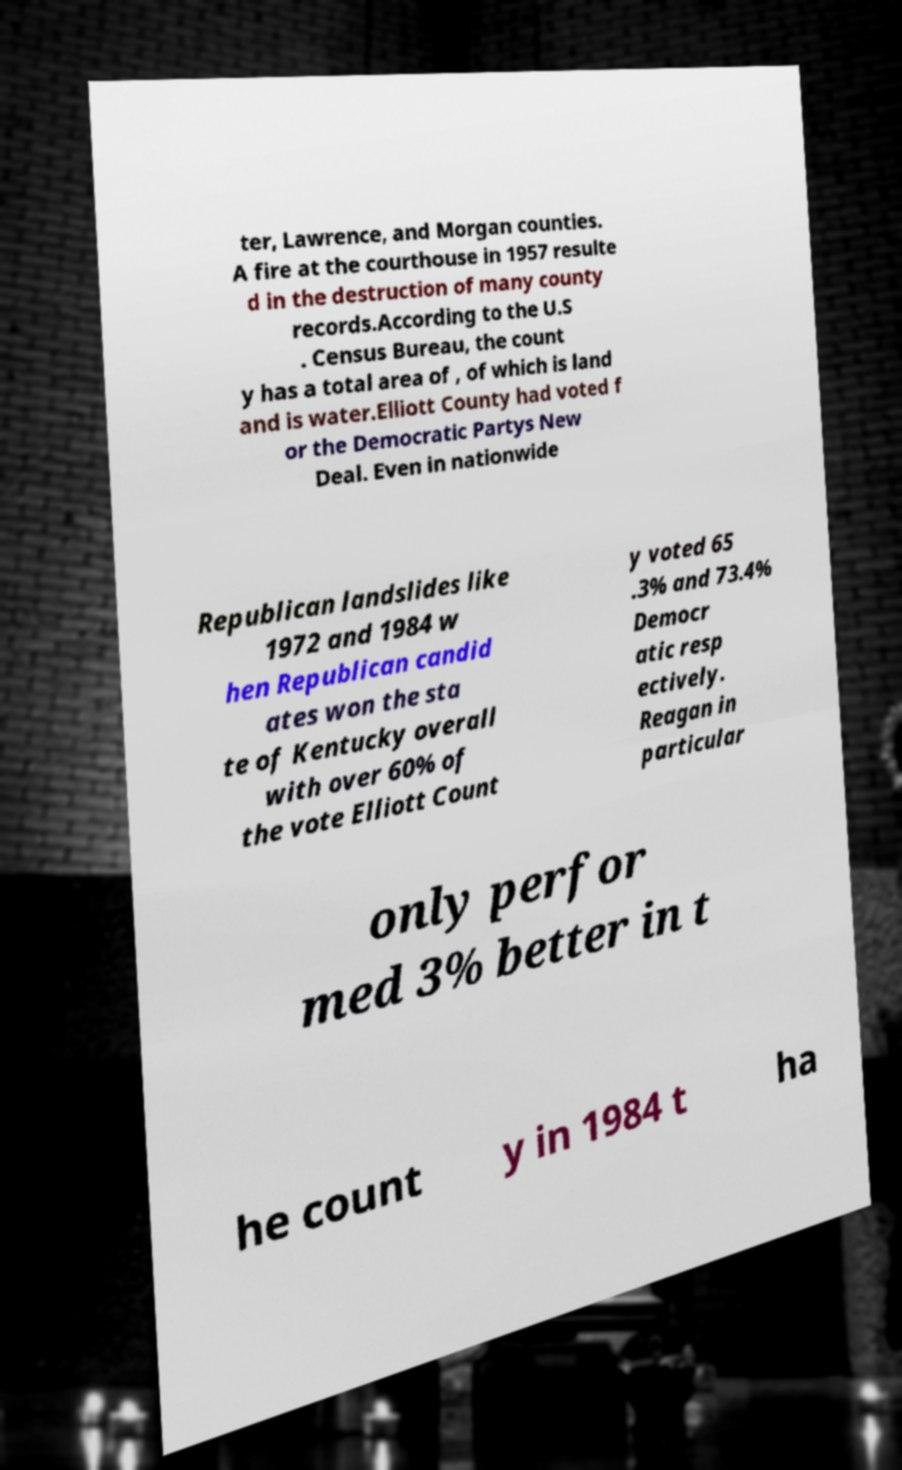Can you read and provide the text displayed in the image?This photo seems to have some interesting text. Can you extract and type it out for me? ter, Lawrence, and Morgan counties. A fire at the courthouse in 1957 resulte d in the destruction of many county records.According to the U.S . Census Bureau, the count y has a total area of , of which is land and is water.Elliott County had voted f or the Democratic Partys New Deal. Even in nationwide Republican landslides like 1972 and 1984 w hen Republican candid ates won the sta te of Kentucky overall with over 60% of the vote Elliott Count y voted 65 .3% and 73.4% Democr atic resp ectively. Reagan in particular only perfor med 3% better in t he count y in 1984 t ha 